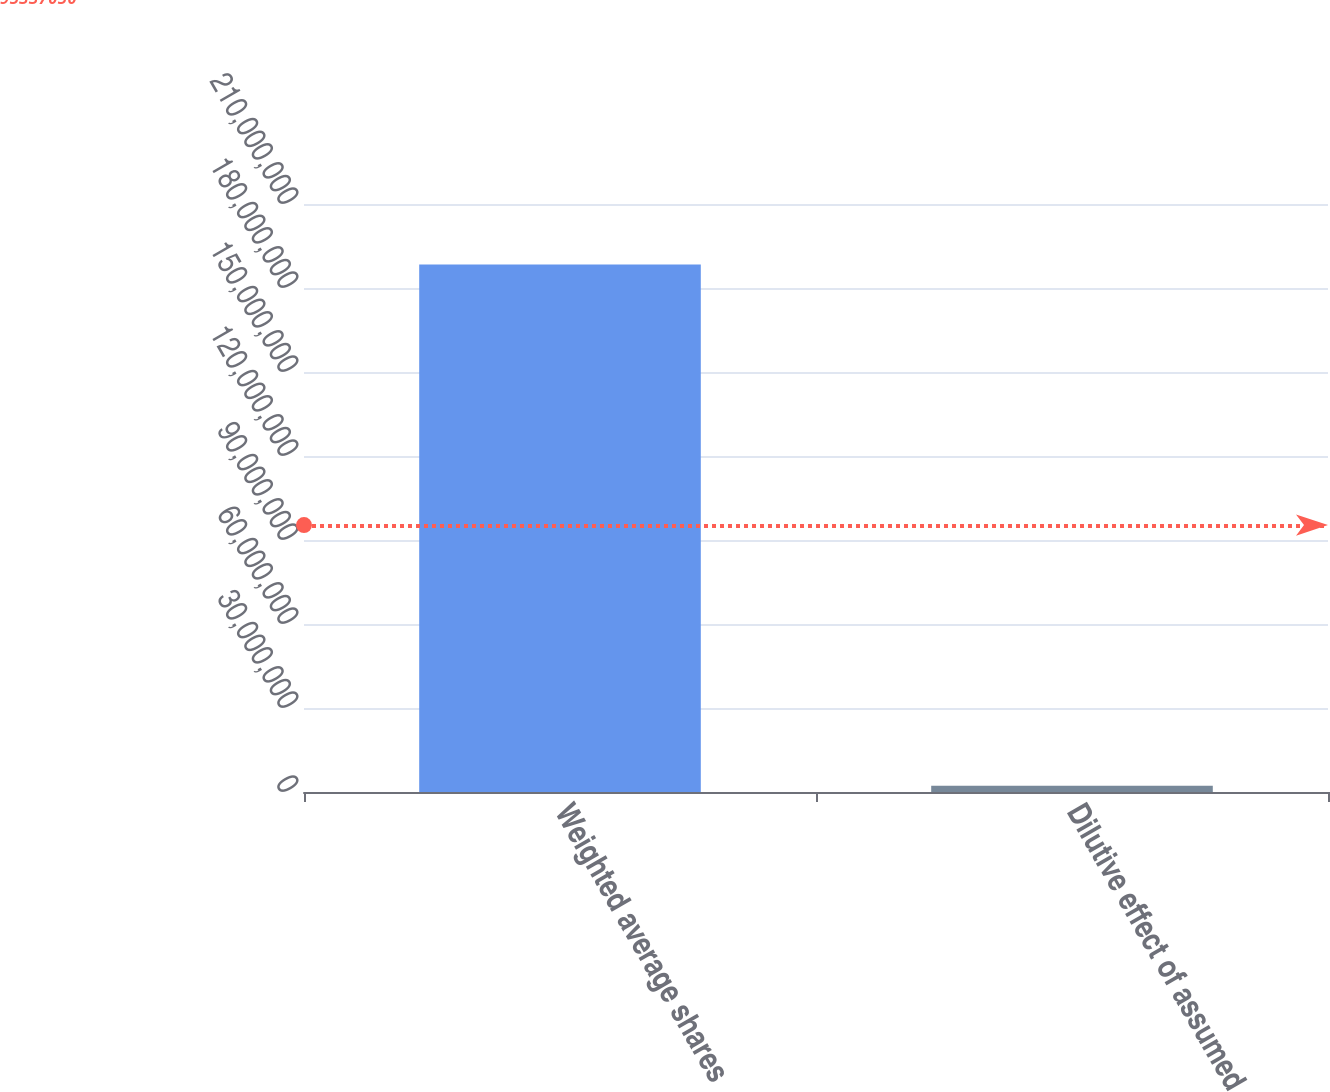Convert chart to OTSL. <chart><loc_0><loc_0><loc_500><loc_500><bar_chart><fcel>Weighted average shares<fcel>Dilutive effect of assumed<nl><fcel>1.88398e+08<fcel>2.276e+06<nl></chart> 